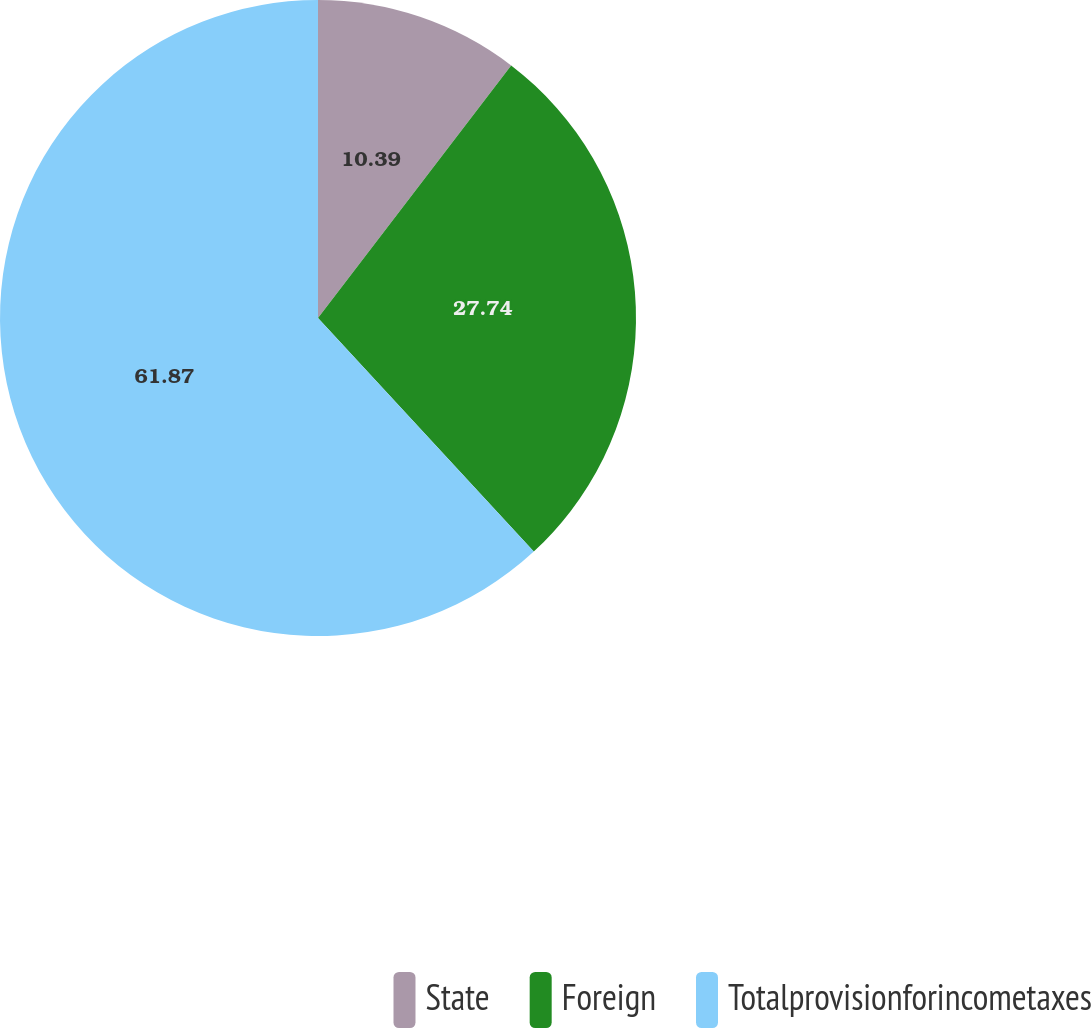Convert chart to OTSL. <chart><loc_0><loc_0><loc_500><loc_500><pie_chart><fcel>State<fcel>Foreign<fcel>Totalprovisionforincometaxes<nl><fcel>10.39%<fcel>27.74%<fcel>61.87%<nl></chart> 